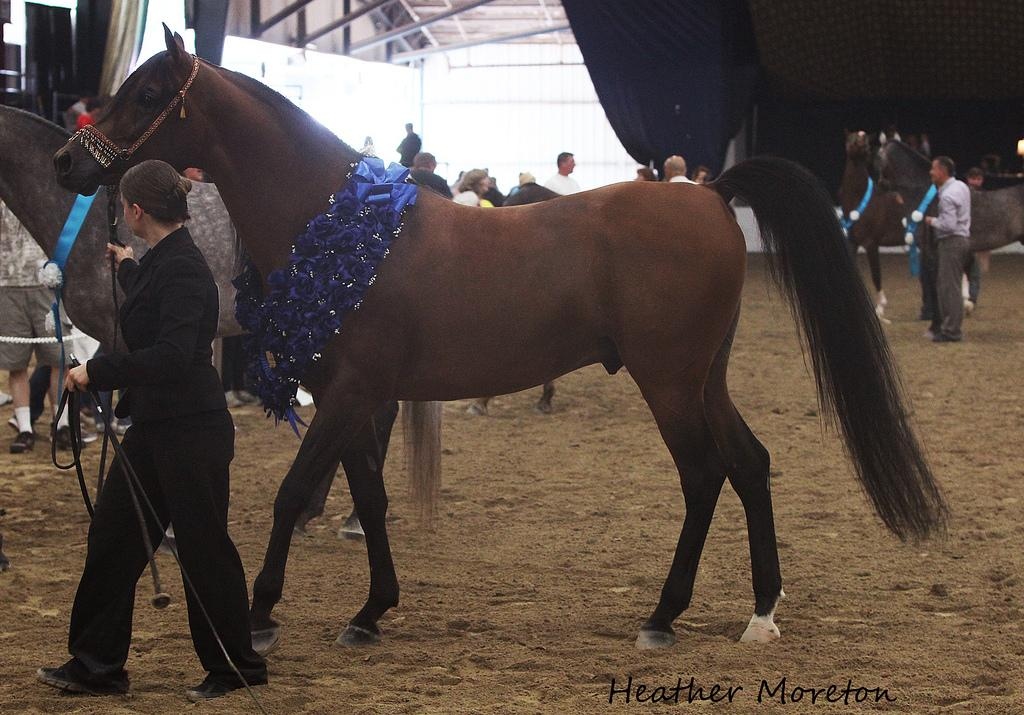How many objects related to the person's clothing are mentioned in the image description, and what are they? Four objects are mentioned: black jacket, gray pants, black pants, and black shoes. Can you provide a short description of the person's outfit in the image? The person is wearing a black jacket, gray pants, black shoes, and has dark hair. What is the woman holding in her hand in the image? The woman is holding the reins of the horse. Identify the animal featured in the image and describe its appearance. The image features a large brown horse with a long black tail, walking next to a person. Provide a brief description of the environment in which the primary subjects of the image are located. The subjects are located in a pen, surrounded by brown dirt and a wall at the side of a building. Which two colors are predominantly featured in the image? The two predominant colors in the image are brown (horse and dirt) and black (clothing and tail). What is the activity of the main characters in this image? A woman is leading a large brown horse, and they are both walking together. 